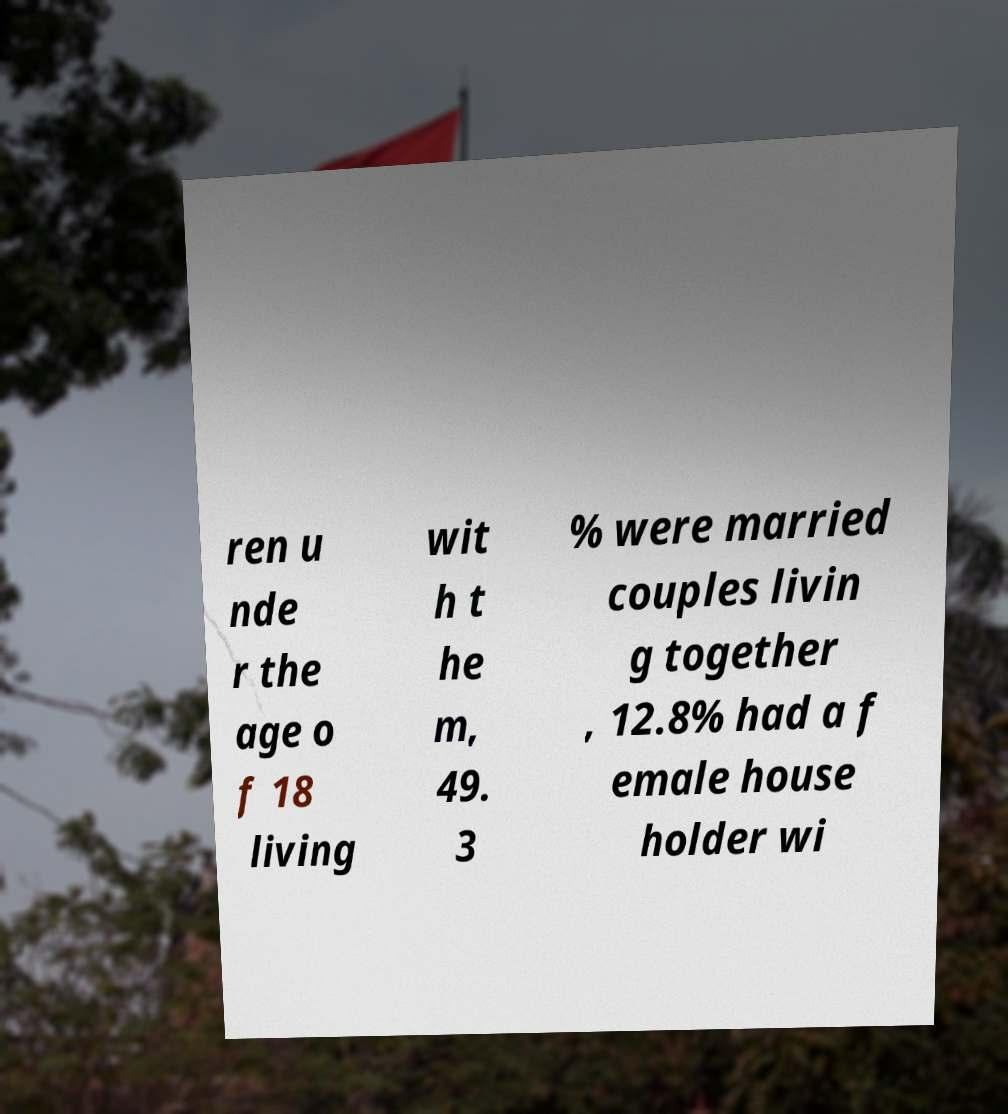Can you accurately transcribe the text from the provided image for me? ren u nde r the age o f 18 living wit h t he m, 49. 3 % were married couples livin g together , 12.8% had a f emale house holder wi 